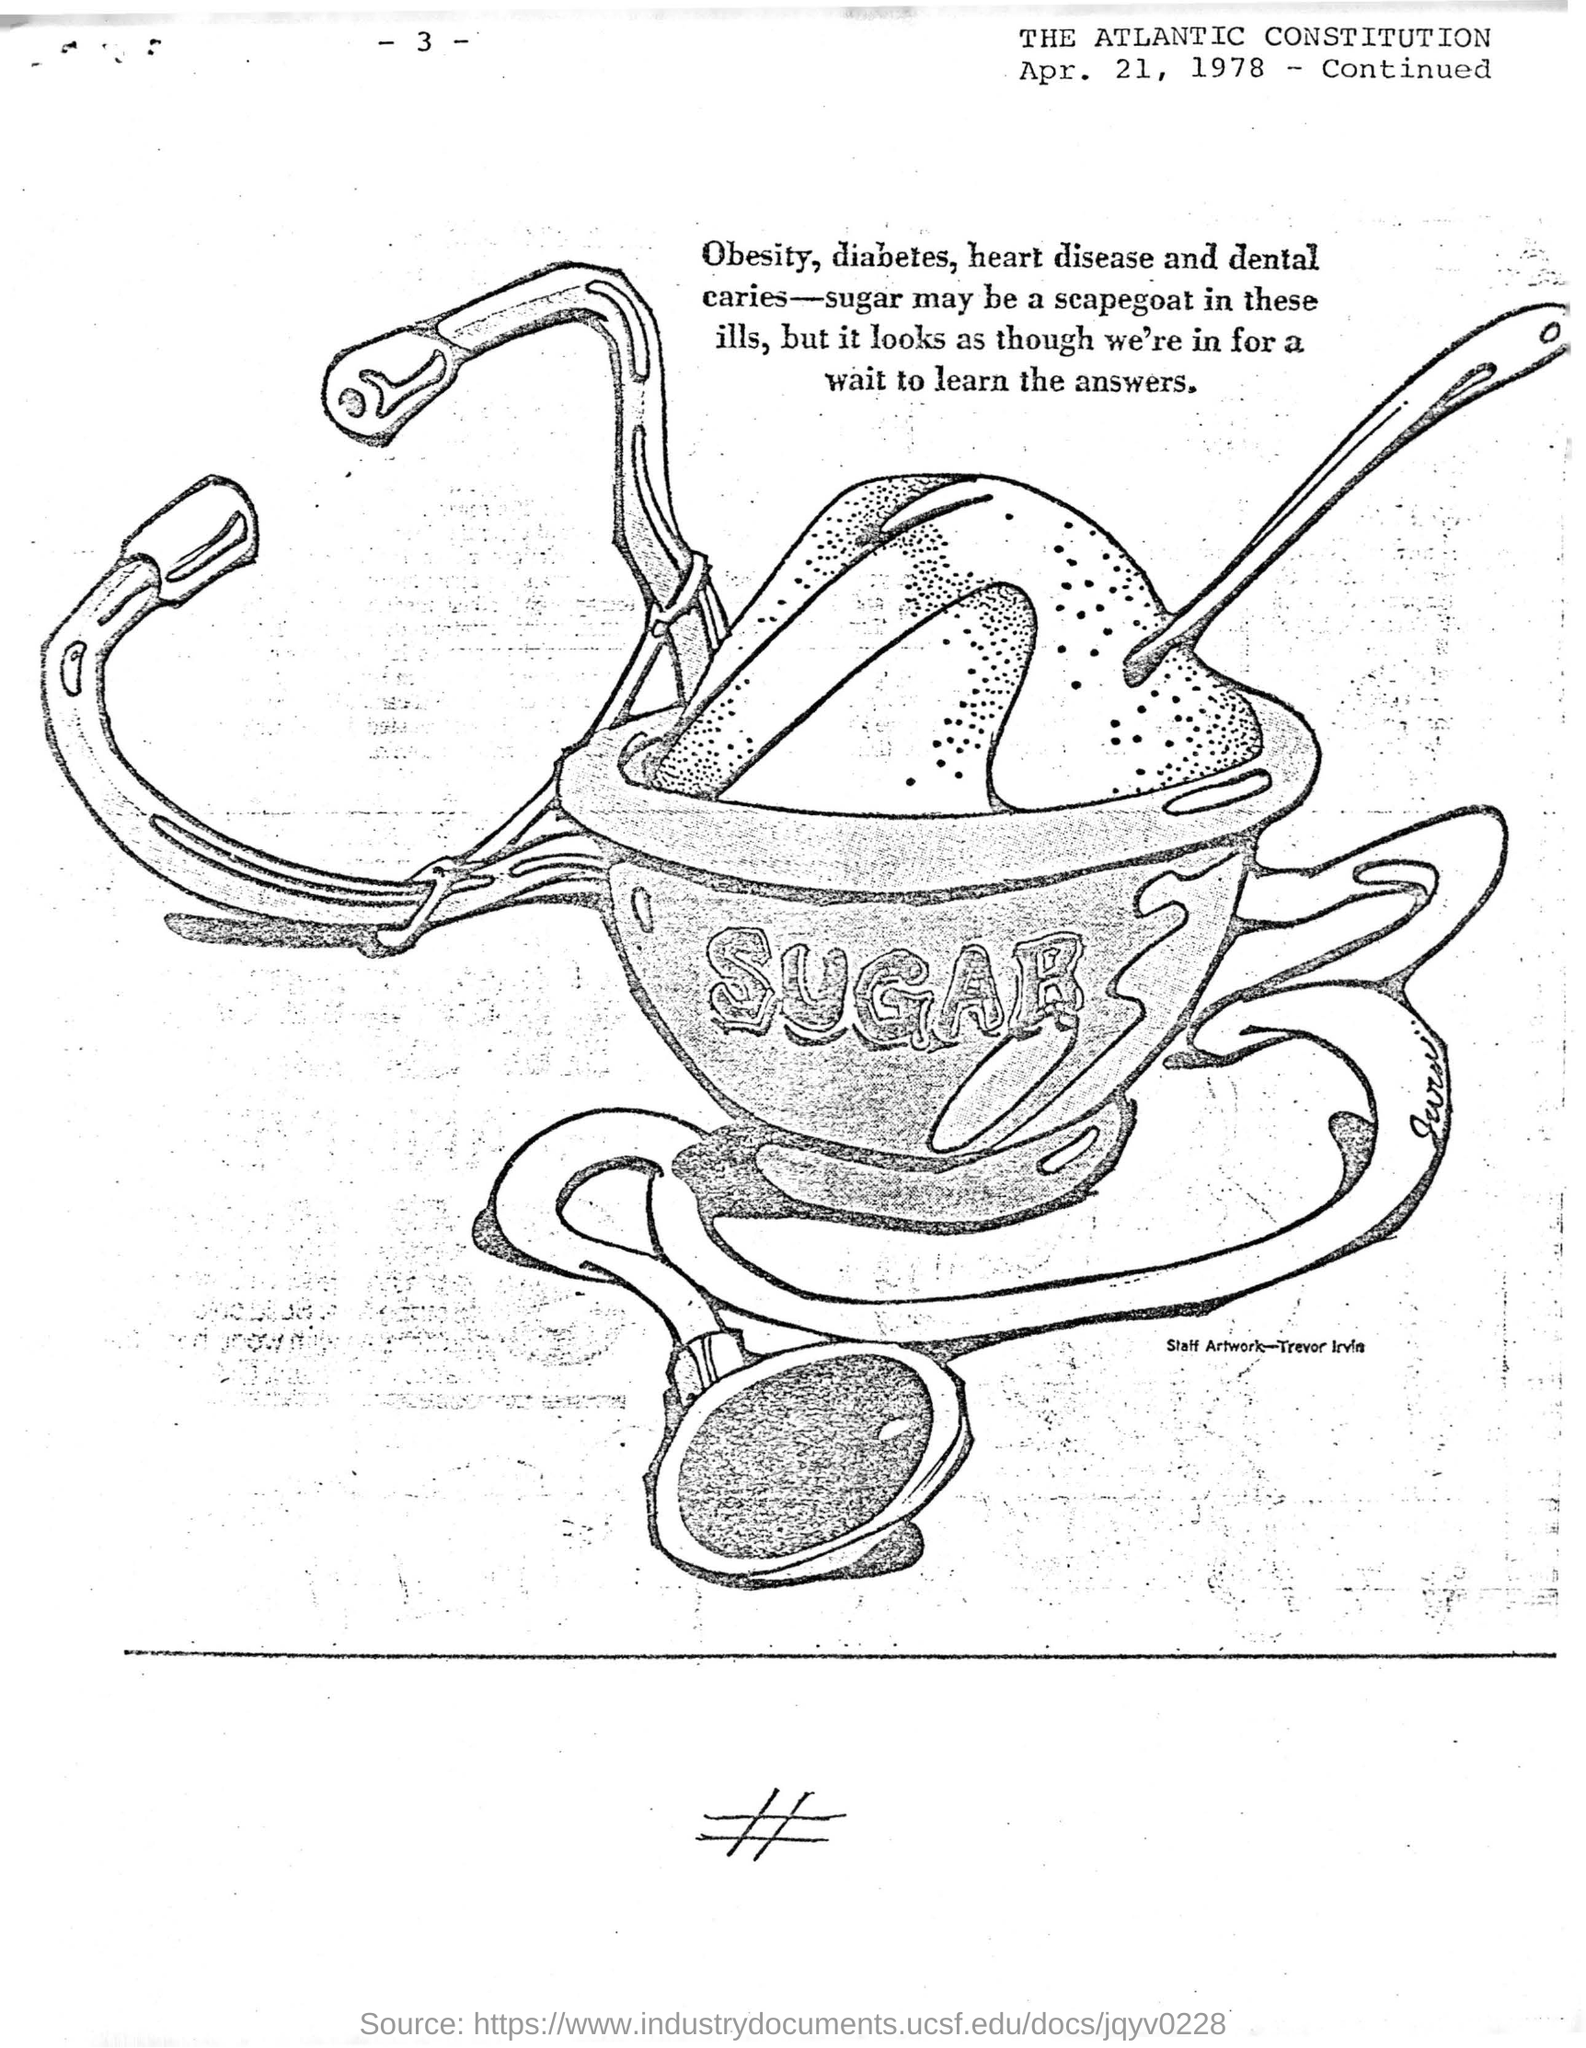Sugar may be a scapegoat in which ills?
Ensure brevity in your answer.  Obesity, diabetes, heart disease and dental caries. What is the date mentioned?
Keep it short and to the point. Apr. 21, 1978. What is the CONSTITUTION's name?
Keep it short and to the point. THE ATLANTIC CONSTITUTION. 